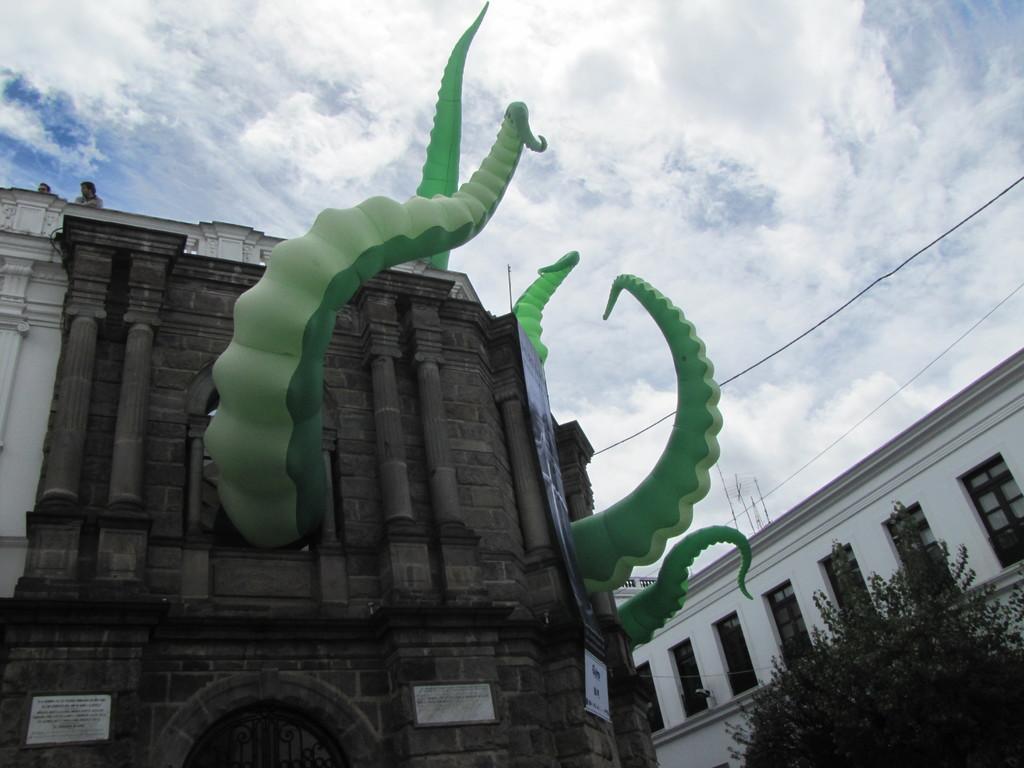Please provide a concise description of this image. In this image there is a building in the middle. There are tentacles coming out from the windows. At the top there is the sky. On the right side bottom there is a tree. Beside the tree there is a building. 